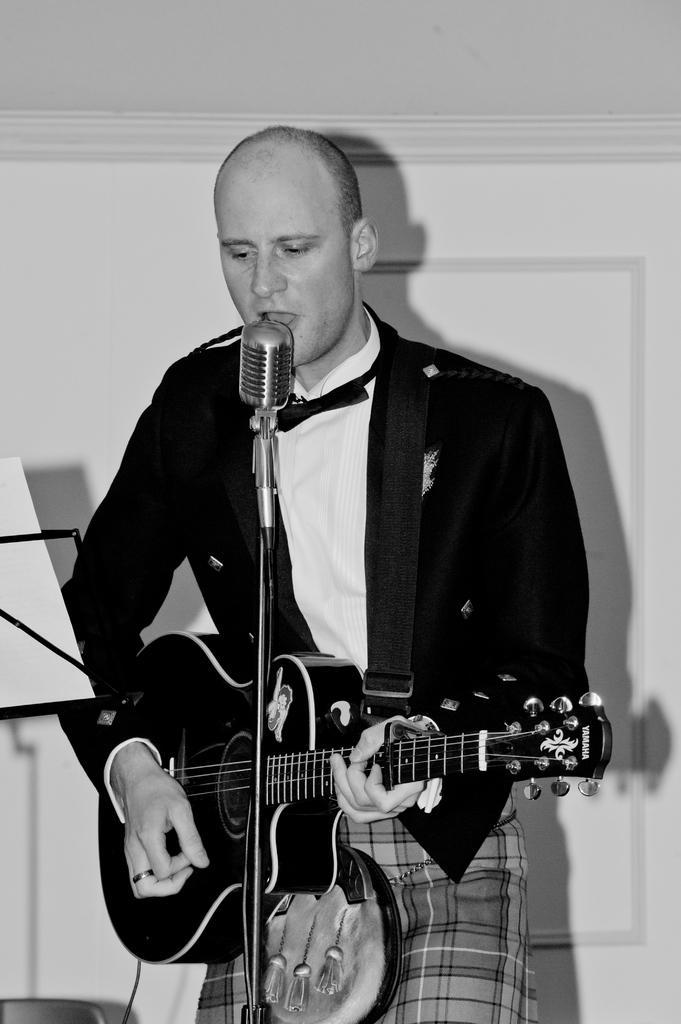In one or two sentences, can you explain what this image depicts? In this image there is a man holding a guitar in his hand and playing and is singing in front of the mic. In the background there is a wall which is white in colour and the man is wearing a black colour jacket. 